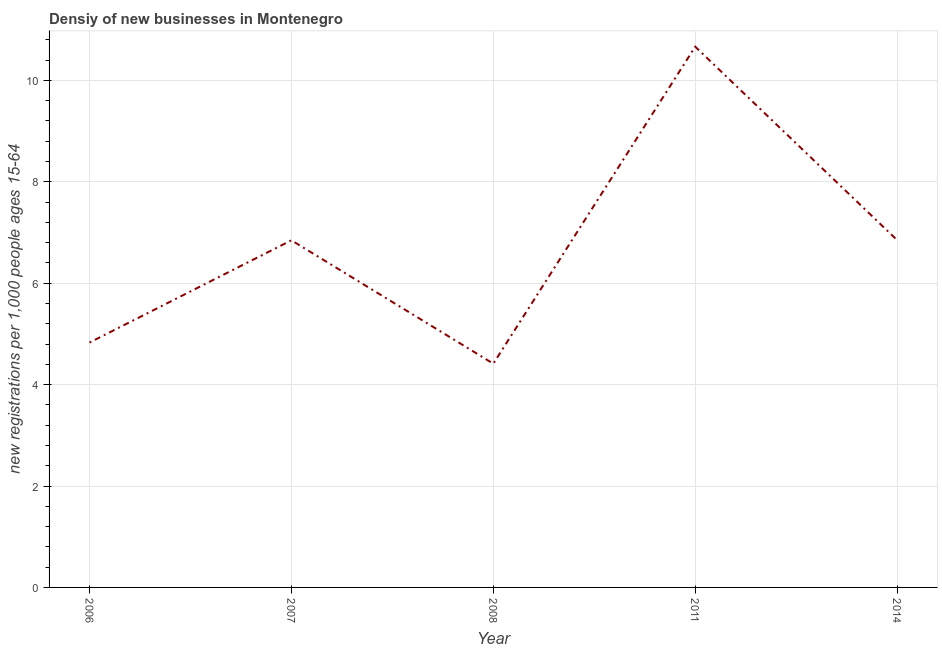What is the density of new business in 2014?
Your answer should be very brief. 6.85. Across all years, what is the maximum density of new business?
Offer a very short reply. 10.66. Across all years, what is the minimum density of new business?
Keep it short and to the point. 4.41. In which year was the density of new business maximum?
Ensure brevity in your answer.  2011. What is the sum of the density of new business?
Provide a succinct answer. 33.6. What is the difference between the density of new business in 2006 and 2011?
Ensure brevity in your answer.  -5.84. What is the average density of new business per year?
Ensure brevity in your answer.  6.72. What is the median density of new business?
Keep it short and to the point. 6.85. Do a majority of the years between 2006 and 2007 (inclusive) have density of new business greater than 7.6 ?
Offer a very short reply. No. What is the ratio of the density of new business in 2006 to that in 2011?
Your response must be concise. 0.45. Is the difference between the density of new business in 2011 and 2014 greater than the difference between any two years?
Your answer should be very brief. No. What is the difference between the highest and the second highest density of new business?
Give a very brief answer. 3.81. What is the difference between the highest and the lowest density of new business?
Provide a succinct answer. 6.25. In how many years, is the density of new business greater than the average density of new business taken over all years?
Provide a short and direct response. 3. Does the density of new business monotonically increase over the years?
Provide a succinct answer. No. How many lines are there?
Make the answer very short. 1. Are the values on the major ticks of Y-axis written in scientific E-notation?
Your answer should be very brief. No. What is the title of the graph?
Offer a very short reply. Densiy of new businesses in Montenegro. What is the label or title of the X-axis?
Ensure brevity in your answer.  Year. What is the label or title of the Y-axis?
Provide a short and direct response. New registrations per 1,0 people ages 15-64. What is the new registrations per 1,000 people ages 15-64 in 2006?
Your answer should be very brief. 4.83. What is the new registrations per 1,000 people ages 15-64 in 2007?
Offer a terse response. 6.85. What is the new registrations per 1,000 people ages 15-64 of 2008?
Make the answer very short. 4.41. What is the new registrations per 1,000 people ages 15-64 in 2011?
Make the answer very short. 10.66. What is the new registrations per 1,000 people ages 15-64 in 2014?
Provide a short and direct response. 6.85. What is the difference between the new registrations per 1,000 people ages 15-64 in 2006 and 2007?
Give a very brief answer. -2.02. What is the difference between the new registrations per 1,000 people ages 15-64 in 2006 and 2008?
Provide a succinct answer. 0.42. What is the difference between the new registrations per 1,000 people ages 15-64 in 2006 and 2011?
Your answer should be very brief. -5.84. What is the difference between the new registrations per 1,000 people ages 15-64 in 2006 and 2014?
Ensure brevity in your answer.  -2.02. What is the difference between the new registrations per 1,000 people ages 15-64 in 2007 and 2008?
Your response must be concise. 2.43. What is the difference between the new registrations per 1,000 people ages 15-64 in 2007 and 2011?
Make the answer very short. -3.82. What is the difference between the new registrations per 1,000 people ages 15-64 in 2007 and 2014?
Make the answer very short. -0. What is the difference between the new registrations per 1,000 people ages 15-64 in 2008 and 2011?
Your response must be concise. -6.25. What is the difference between the new registrations per 1,000 people ages 15-64 in 2008 and 2014?
Provide a short and direct response. -2.44. What is the difference between the new registrations per 1,000 people ages 15-64 in 2011 and 2014?
Your answer should be very brief. 3.81. What is the ratio of the new registrations per 1,000 people ages 15-64 in 2006 to that in 2007?
Your answer should be compact. 0.7. What is the ratio of the new registrations per 1,000 people ages 15-64 in 2006 to that in 2008?
Ensure brevity in your answer.  1.09. What is the ratio of the new registrations per 1,000 people ages 15-64 in 2006 to that in 2011?
Your answer should be compact. 0.45. What is the ratio of the new registrations per 1,000 people ages 15-64 in 2006 to that in 2014?
Offer a very short reply. 0.7. What is the ratio of the new registrations per 1,000 people ages 15-64 in 2007 to that in 2008?
Offer a very short reply. 1.55. What is the ratio of the new registrations per 1,000 people ages 15-64 in 2007 to that in 2011?
Make the answer very short. 0.64. What is the ratio of the new registrations per 1,000 people ages 15-64 in 2008 to that in 2011?
Your answer should be compact. 0.41. What is the ratio of the new registrations per 1,000 people ages 15-64 in 2008 to that in 2014?
Your answer should be very brief. 0.64. What is the ratio of the new registrations per 1,000 people ages 15-64 in 2011 to that in 2014?
Provide a short and direct response. 1.56. 